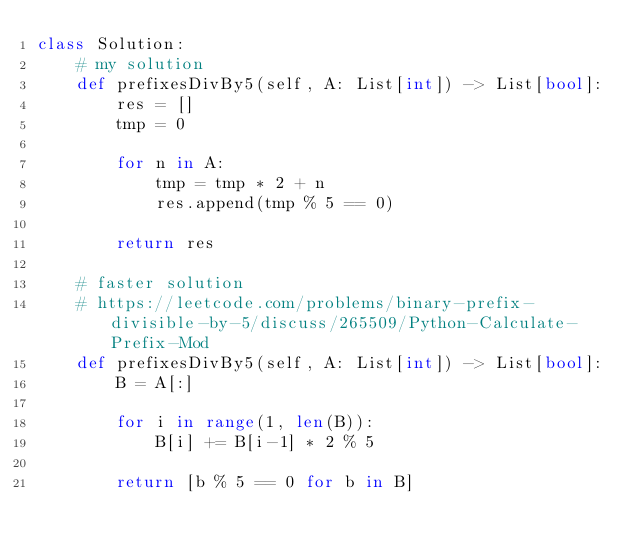<code> <loc_0><loc_0><loc_500><loc_500><_Python_>class Solution:
    # my solution
    def prefixesDivBy5(self, A: List[int]) -> List[bool]:
        res = []
        tmp = 0
        
        for n in A:
            tmp = tmp * 2 + n
            res.append(tmp % 5 == 0)
            
        return res
    
    # faster solution
    # https://leetcode.com/problems/binary-prefix-divisible-by-5/discuss/265509/Python-Calculate-Prefix-Mod
    def prefixesDivBy5(self, A: List[int]) -> List[bool]:
        B = A[:]
        
        for i in range(1, len(B)):
            B[i] += B[i-1] * 2 % 5
            
        return [b % 5 == 0 for b in B]</code> 